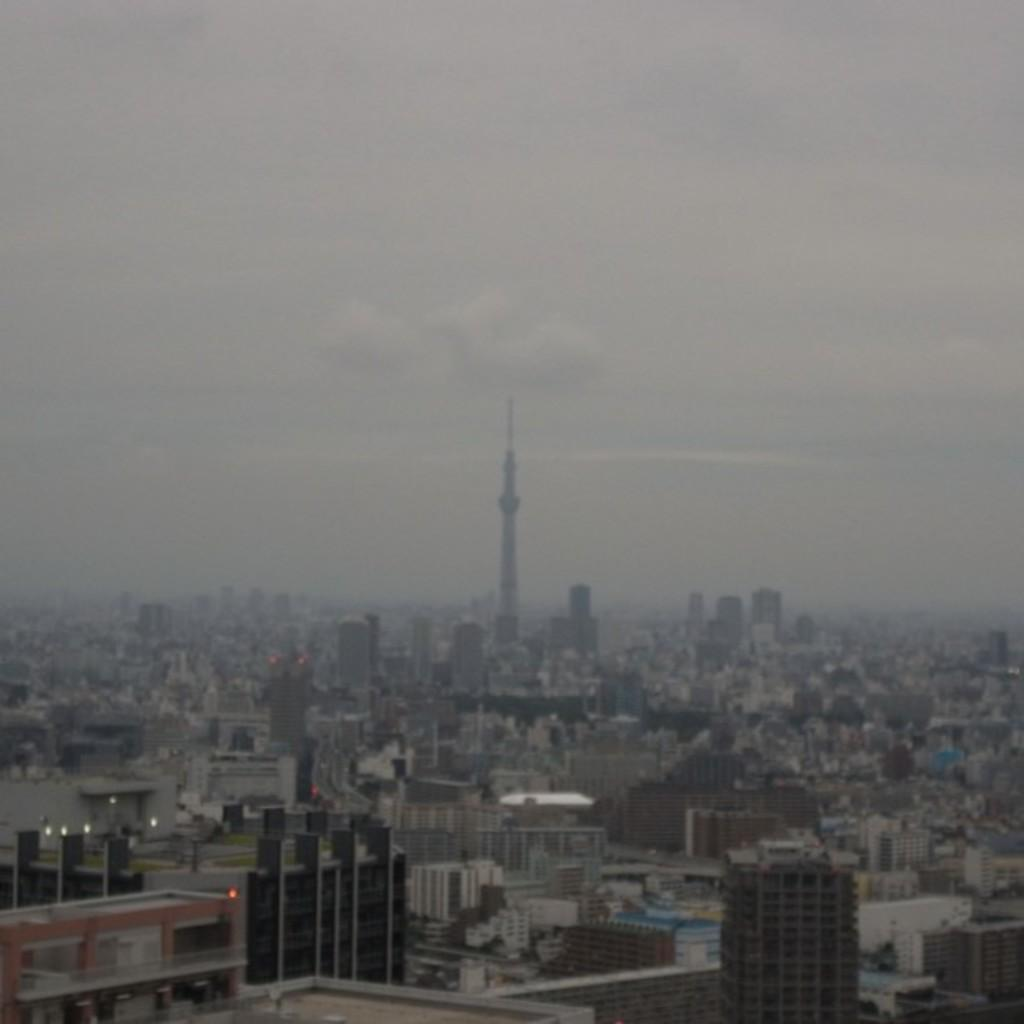What type of structures can be seen in the image? There are buildings in the image, including a tall tower. What is visible in the background of the image? There is a sky visible in the background of the image. What can be observed in the sky? There are clouds in the sky. How many cats are sitting on the tall tower in the image? There are no cats present in the image; it features buildings and a sky with clouds. 